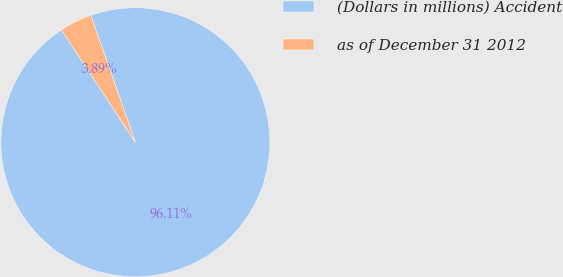Convert chart to OTSL. <chart><loc_0><loc_0><loc_500><loc_500><pie_chart><fcel>(Dollars in millions) Accident<fcel>as of December 31 2012<nl><fcel>96.11%<fcel>3.89%<nl></chart> 